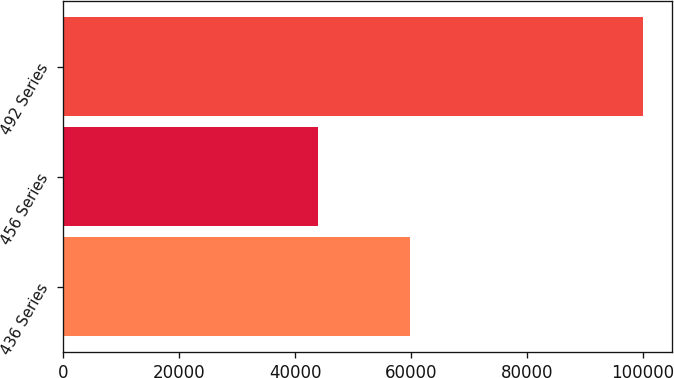Convert chart. <chart><loc_0><loc_0><loc_500><loc_500><bar_chart><fcel>436 Series<fcel>456 Series<fcel>492 Series<nl><fcel>59920<fcel>43887<fcel>100000<nl></chart> 